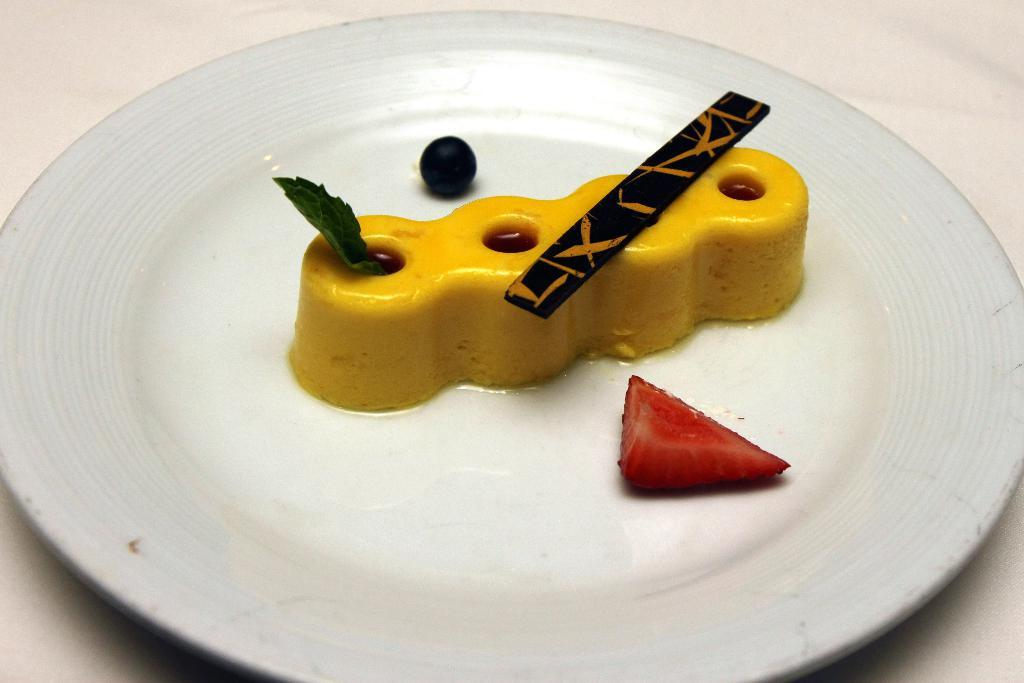What is on the plate that is visible in the image? There are food items on a plate in the image. What color is the plate? The plate is white. What can be seen in the background of the image? The background of the image is white. How does the chicken wave its wings in the image? There is no chicken present in the image, so it cannot wave its wings. 